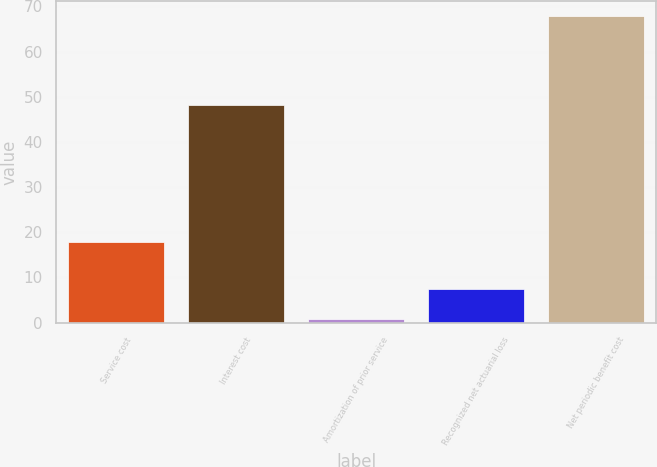<chart> <loc_0><loc_0><loc_500><loc_500><bar_chart><fcel>Service cost<fcel>Interest cost<fcel>Amortization of prior service<fcel>Recognized net actuarial loss<fcel>Net periodic benefit cost<nl><fcel>17.8<fcel>48.2<fcel>0.7<fcel>7.41<fcel>67.8<nl></chart> 